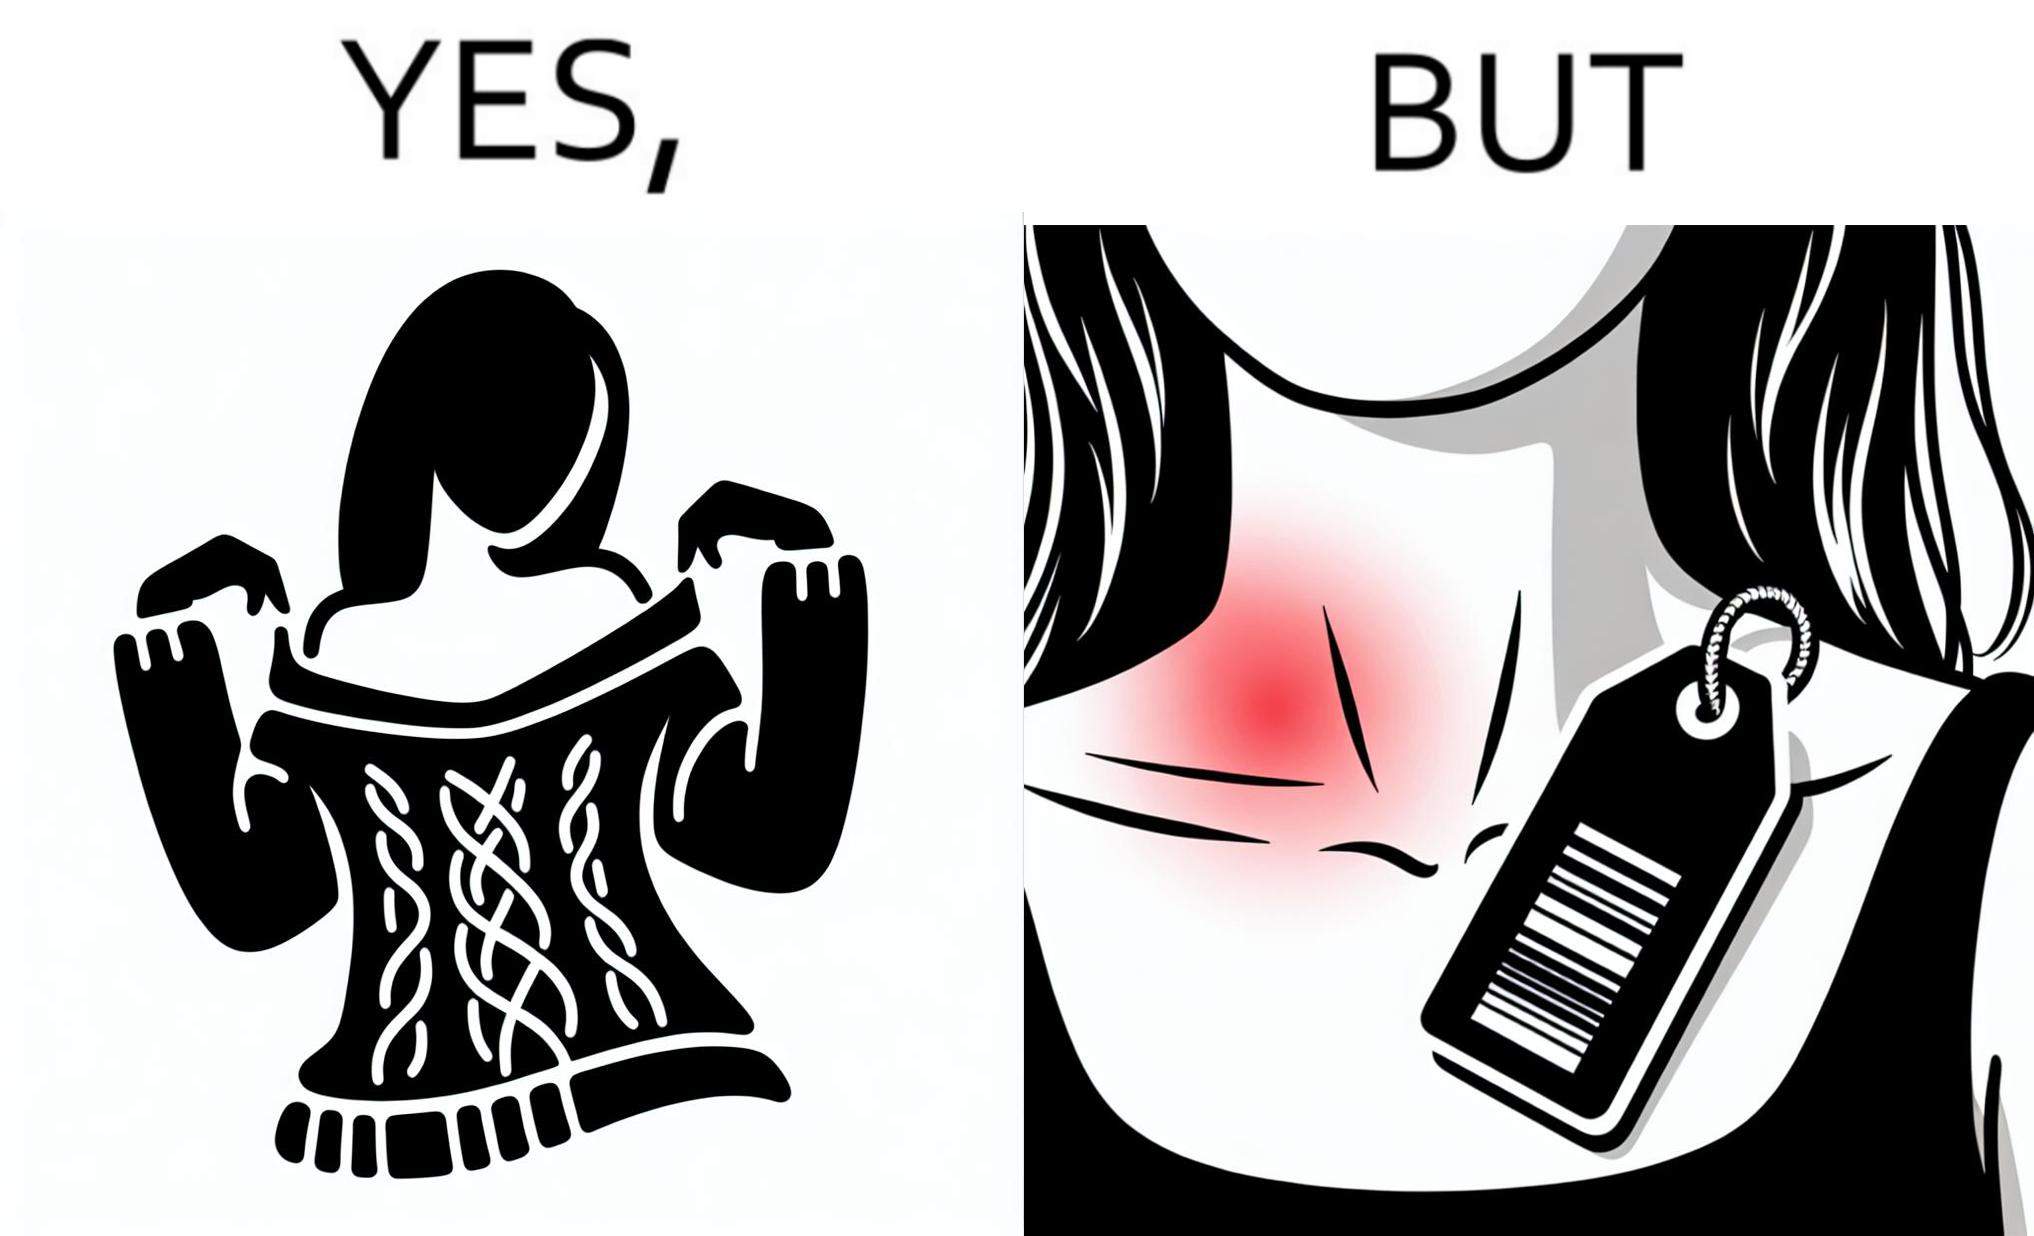Describe what you see in the left and right parts of this image. In the left part of the image: It is a woman enjoying the warmth and comfort of her sweater In the right part of the image: It a womans neck, irritated and red due to manufacturers tags on her clothes 